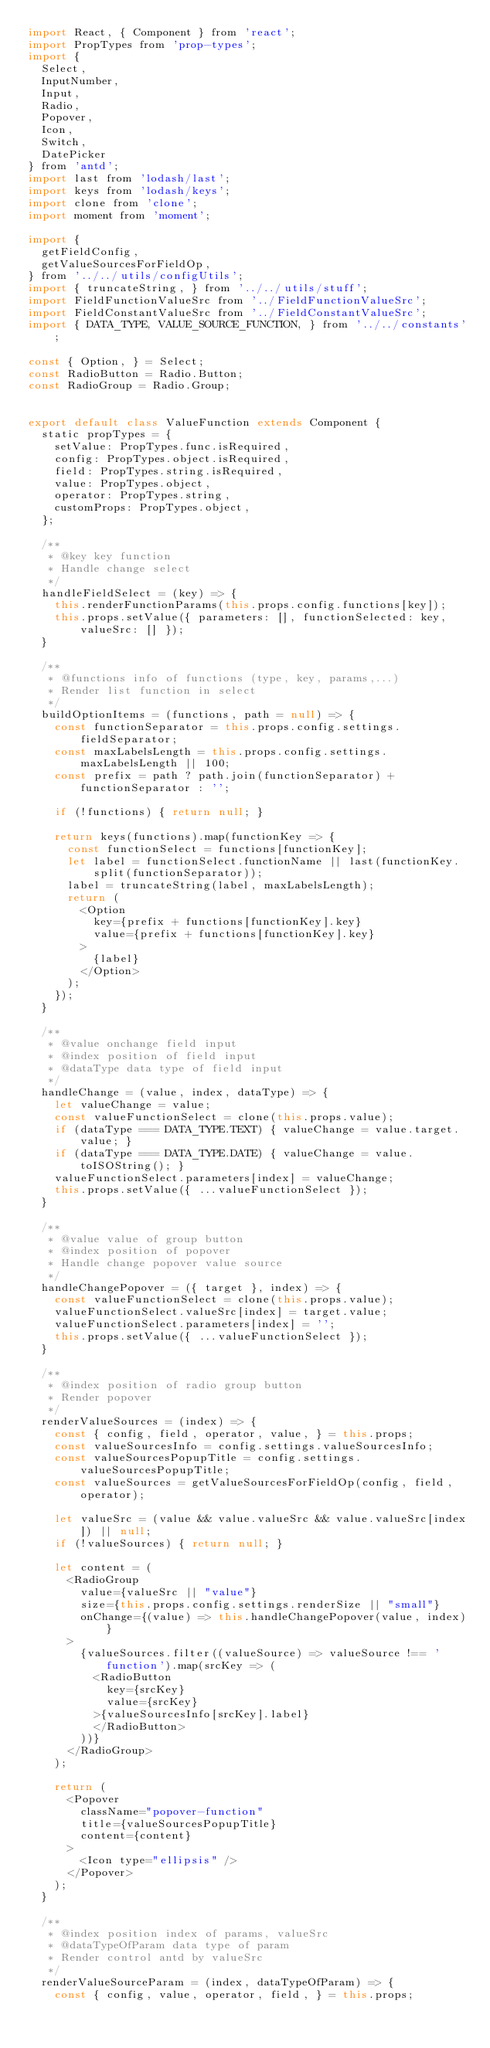<code> <loc_0><loc_0><loc_500><loc_500><_JavaScript_>import React, { Component } from 'react';
import PropTypes from 'prop-types';
import {
  Select,
  InputNumber,
  Input,
  Radio,
  Popover,
  Icon,
  Switch,
  DatePicker
} from 'antd';
import last from 'lodash/last';
import keys from 'lodash/keys';
import clone from 'clone';
import moment from 'moment';

import {
  getFieldConfig,
  getValueSourcesForFieldOp,
} from '../../utils/configUtils';
import { truncateString, } from '../../utils/stuff';
import FieldFunctionValueSrc from '../FieldFunctionValueSrc';
import FieldConstantValueSrc from '../FieldConstantValueSrc';
import { DATA_TYPE, VALUE_SOURCE_FUNCTION, } from '../../constants';

const { Option, } = Select;
const RadioButton = Radio.Button;
const RadioGroup = Radio.Group;


export default class ValueFunction extends Component {
  static propTypes = {
    setValue: PropTypes.func.isRequired,
    config: PropTypes.object.isRequired,
    field: PropTypes.string.isRequired,
    value: PropTypes.object,
    operator: PropTypes.string,
    customProps: PropTypes.object,
  };

  /**
   * @key key function
   * Handle change select
   */
  handleFieldSelect = (key) => {
    this.renderFunctionParams(this.props.config.functions[key]);
    this.props.setValue({ parameters: [], functionSelected: key, valueSrc: [] });
  }

  /**
   * @functions info of functions (type, key, params,...)
   * Render list function in select
   */
  buildOptionItems = (functions, path = null) => {
    const functionSeparator = this.props.config.settings.fieldSeparator;
    const maxLabelsLength = this.props.config.settings.maxLabelsLength || 100;
    const prefix = path ? path.join(functionSeparator) + functionSeparator : '';

    if (!functions) { return null; }

    return keys(functions).map(functionKey => {
      const functionSelect = functions[functionKey];
      let label = functionSelect.functionName || last(functionKey.split(functionSeparator));
      label = truncateString(label, maxLabelsLength);
      return (
        <Option
          key={prefix + functions[functionKey].key}
          value={prefix + functions[functionKey].key}
        >
          {label}
        </Option>
      );
    });
  }

  /**
   * @value onchange field input
   * @index position of field input
   * @dataType data type of field input
   */
  handleChange = (value, index, dataType) => {
    let valueChange = value;
    const valueFunctionSelect = clone(this.props.value);
    if (dataType === DATA_TYPE.TEXT) { valueChange = value.target.value; }
    if (dataType === DATA_TYPE.DATE) { valueChange = value.toISOString(); }
    valueFunctionSelect.parameters[index] = valueChange;
    this.props.setValue({ ...valueFunctionSelect });
  }

  /**
   * @value value of group button
   * @index position of popover
   * Handle change popover value source
   */
  handleChangePopover = ({ target }, index) => {
    const valueFunctionSelect = clone(this.props.value);
    valueFunctionSelect.valueSrc[index] = target.value;
    valueFunctionSelect.parameters[index] = '';
    this.props.setValue({ ...valueFunctionSelect });
  }

  /**
   * @index position of radio group button
   * Render popover
   */
  renderValueSources = (index) => {
    const { config, field, operator, value, } = this.props;
    const valueSourcesInfo = config.settings.valueSourcesInfo;
    const valueSourcesPopupTitle = config.settings.valueSourcesPopupTitle;
    const valueSources = getValueSourcesForFieldOp(config, field, operator);

    let valueSrc = (value && value.valueSrc && value.valueSrc[index]) || null;
    if (!valueSources) { return null; }

    let content = (
      <RadioGroup
        value={valueSrc || "value"}
        size={this.props.config.settings.renderSize || "small"}
        onChange={(value) => this.handleChangePopover(value, index)}
      >
        {valueSources.filter((valueSource) => valueSource !== 'function').map(srcKey => (
          <RadioButton
            key={srcKey}
            value={srcKey}
          >{valueSourcesInfo[srcKey].label}
          </RadioButton>
        ))}
      </RadioGroup>
    );

    return (
      <Popover
        className="popover-function"
        title={valueSourcesPopupTitle}
        content={content}
      >
        <Icon type="ellipsis" />
      </Popover>
    );
  }

  /**
   * @index position index of params, valueSrc
   * @dataTypeOfParam data type of param
   * Render control antd by valueSrc
   */
  renderValueSourceParam = (index, dataTypeOfParam) => {
    const { config, value, operator, field, } = this.props;</code> 